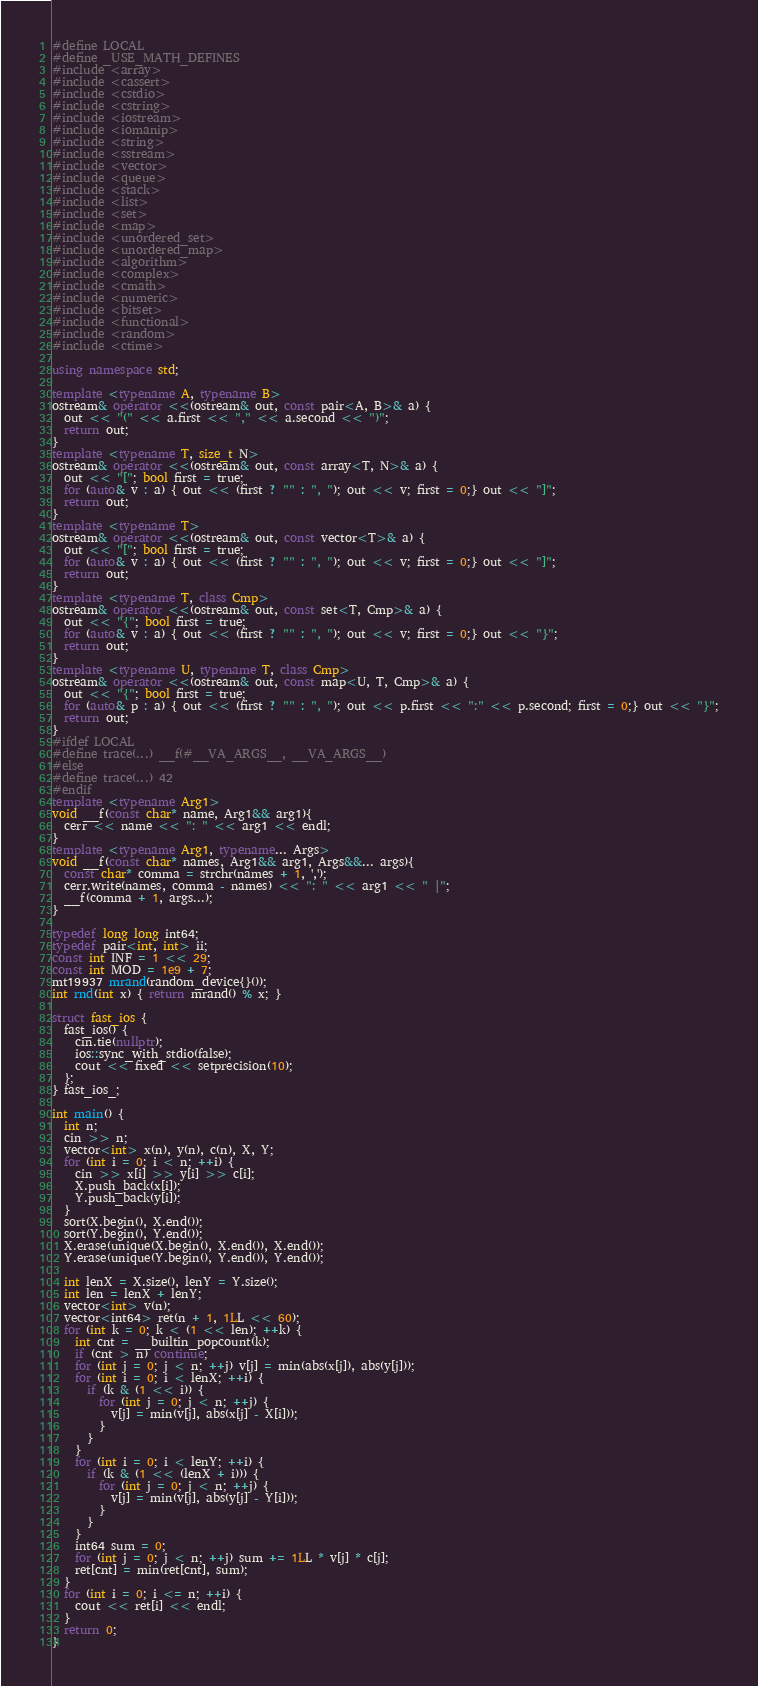<code> <loc_0><loc_0><loc_500><loc_500><_C++_>#define LOCAL
#define _USE_MATH_DEFINES
#include <array>
#include <cassert>
#include <cstdio>
#include <cstring>
#include <iostream>
#include <iomanip>
#include <string>
#include <sstream>
#include <vector>
#include <queue>
#include <stack>
#include <list>
#include <set>
#include <map>
#include <unordered_set>
#include <unordered_map>
#include <algorithm>
#include <complex>
#include <cmath>
#include <numeric>
#include <bitset>
#include <functional>
#include <random>
#include <ctime>

using namespace std;

template <typename A, typename B>
ostream& operator <<(ostream& out, const pair<A, B>& a) {
  out << "(" << a.first << "," << a.second << ")";
  return out;
}
template <typename T, size_t N>
ostream& operator <<(ostream& out, const array<T, N>& a) {
  out << "["; bool first = true;
  for (auto& v : a) { out << (first ? "" : ", "); out << v; first = 0;} out << "]";
  return out;
}
template <typename T>
ostream& operator <<(ostream& out, const vector<T>& a) {
  out << "["; bool first = true;
  for (auto& v : a) { out << (first ? "" : ", "); out << v; first = 0;} out << "]";
  return out;
}
template <typename T, class Cmp>
ostream& operator <<(ostream& out, const set<T, Cmp>& a) {
  out << "{"; bool first = true;
  for (auto& v : a) { out << (first ? "" : ", "); out << v; first = 0;} out << "}";
  return out;
}
template <typename U, typename T, class Cmp>
ostream& operator <<(ostream& out, const map<U, T, Cmp>& a) {
  out << "{"; bool first = true;
  for (auto& p : a) { out << (first ? "" : ", "); out << p.first << ":" << p.second; first = 0;} out << "}";
  return out;
}
#ifdef LOCAL
#define trace(...) __f(#__VA_ARGS__, __VA_ARGS__)
#else
#define trace(...) 42
#endif
template <typename Arg1>
void __f(const char* name, Arg1&& arg1){
  cerr << name << ": " << arg1 << endl;
}
template <typename Arg1, typename... Args>
void __f(const char* names, Arg1&& arg1, Args&&... args){
  const char* comma = strchr(names + 1, ',');
  cerr.write(names, comma - names) << ": " << arg1 << " |";
  __f(comma + 1, args...);
}

typedef long long int64;
typedef pair<int, int> ii;
const int INF = 1 << 29;
const int MOD = 1e9 + 7;
mt19937 mrand(random_device{}());
int rnd(int x) { return mrand() % x; }

struct fast_ios {
  fast_ios() {
    cin.tie(nullptr);
    ios::sync_with_stdio(false);
    cout << fixed << setprecision(10);
  };
} fast_ios_;

int main() {
  int n;
  cin >> n;
  vector<int> x(n), y(n), c(n), X, Y;
  for (int i = 0; i < n; ++i) {
    cin >> x[i] >> y[i] >> c[i];
    X.push_back(x[i]);
    Y.push_back(y[i]);
  }
  sort(X.begin(), X.end());
  sort(Y.begin(), Y.end());
  X.erase(unique(X.begin(), X.end()), X.end());
  Y.erase(unique(Y.begin(), Y.end()), Y.end());

  int lenX = X.size(), lenY = Y.size();
  int len = lenX + lenY;
  vector<int> v(n);
  vector<int64> ret(n + 1, 1LL << 60);
  for (int k = 0; k < (1 << len); ++k) {
    int cnt = __builtin_popcount(k);
    if (cnt > n) continue;
    for (int j = 0; j < n; ++j) v[j] = min(abs(x[j]), abs(y[j]));
    for (int i = 0; i < lenX; ++i) {
      if (k & (1 << i)) {
        for (int j = 0; j < n; ++j) {
          v[j] = min(v[j], abs(x[j] - X[i]));
        }
      }
    }
    for (int i = 0; i < lenY; ++i) {
      if (k & (1 << (lenX + i))) {
        for (int j = 0; j < n; ++j) {
          v[j] = min(v[j], abs(y[j] - Y[i]));
        }
      }
    }
    int64 sum = 0;
    for (int j = 0; j < n; ++j) sum += 1LL * v[j] * c[j];
    ret[cnt] = min(ret[cnt], sum);
  }
  for (int i = 0; i <= n; ++i) {
    cout << ret[i] << endl;
  }
  return 0;
}
</code> 